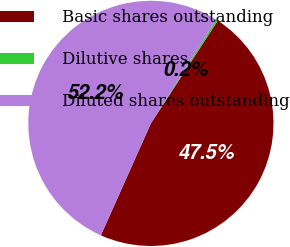Convert chart to OTSL. <chart><loc_0><loc_0><loc_500><loc_500><pie_chart><fcel>Basic shares outstanding<fcel>Dilutive shares<fcel>Diluted shares outstanding<nl><fcel>47.5%<fcel>0.25%<fcel>52.25%<nl></chart> 